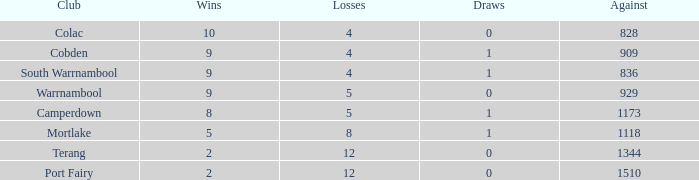What is the sum of wins for Port Fairy with under 1510 against? None. 